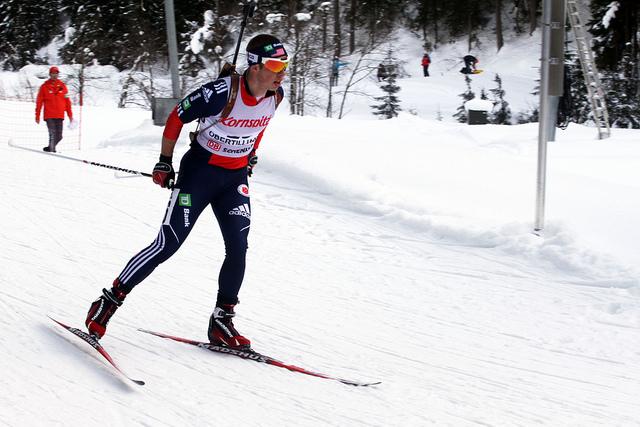Are both ski's touching the ground?
Quick response, please. No. Is the snow covering the ground?
Quick response, please. Yes. What color are the mans goggles?
Quick response, please. Orange. 